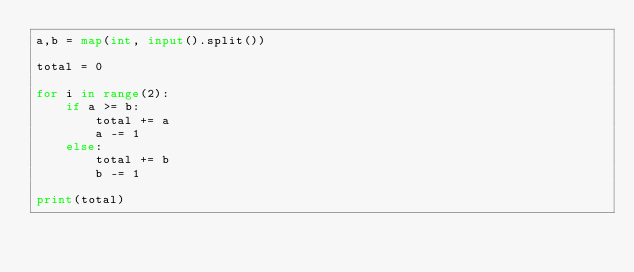<code> <loc_0><loc_0><loc_500><loc_500><_Python_>a,b = map(int, input().split())

total = 0

for i in range(2):
    if a >= b:
        total += a
        a -= 1
    else:
        total += b
        b -= 1

print(total)</code> 